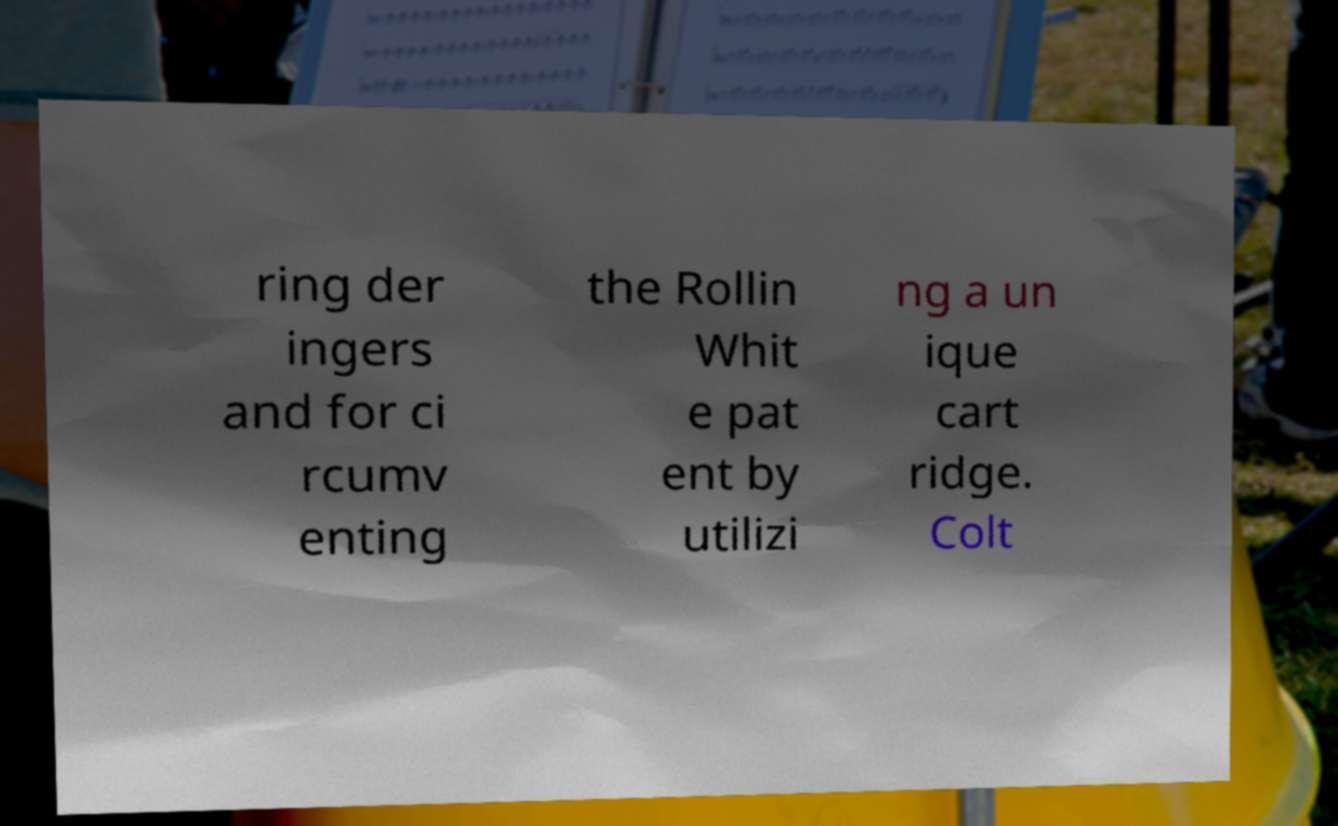For documentation purposes, I need the text within this image transcribed. Could you provide that? ring der ingers and for ci rcumv enting the Rollin Whit e pat ent by utilizi ng a un ique cart ridge. Colt 